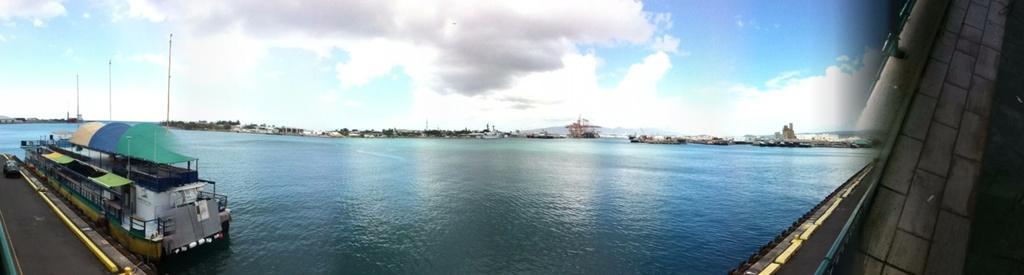Describe this image in one or two sentences. In this image we can see a walkway, boat, poles, tires, water, vehicle and other objects. In the background of the image there are trees, buildings and other objects. At the top of the image there is the sky. On the right side of the image there is an object. 